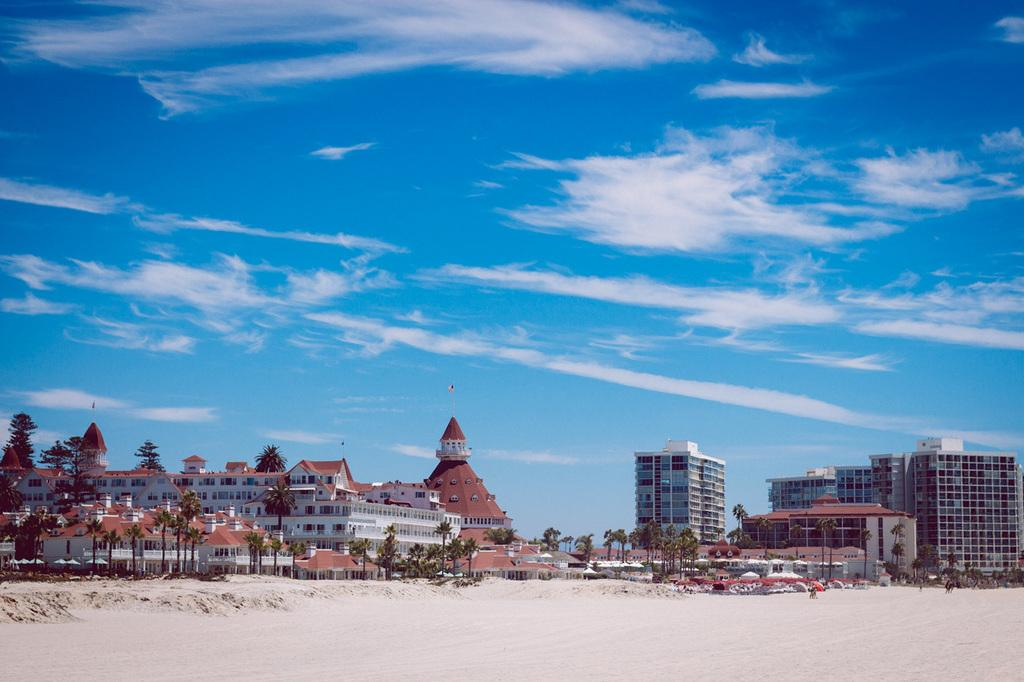What type of terrain is visible in the front of the image? There is land in the front of the image. What type of vegetation can be seen in the image? There are trees in the image. What type of man-made structures are present in the image? There are buildings in the image. What is visible at the top of the image? The sky is visible at the top of the image. Where is the faucet located in the image? There is no faucet present in the image. What type of spot can be seen on the trees in the image? There are no spots visible on the trees in the image. 